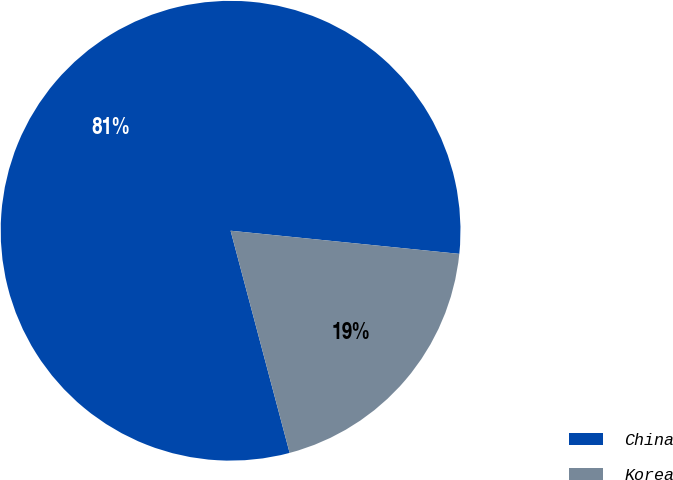Convert chart. <chart><loc_0><loc_0><loc_500><loc_500><pie_chart><fcel>China<fcel>Korea<nl><fcel>80.74%<fcel>19.26%<nl></chart> 